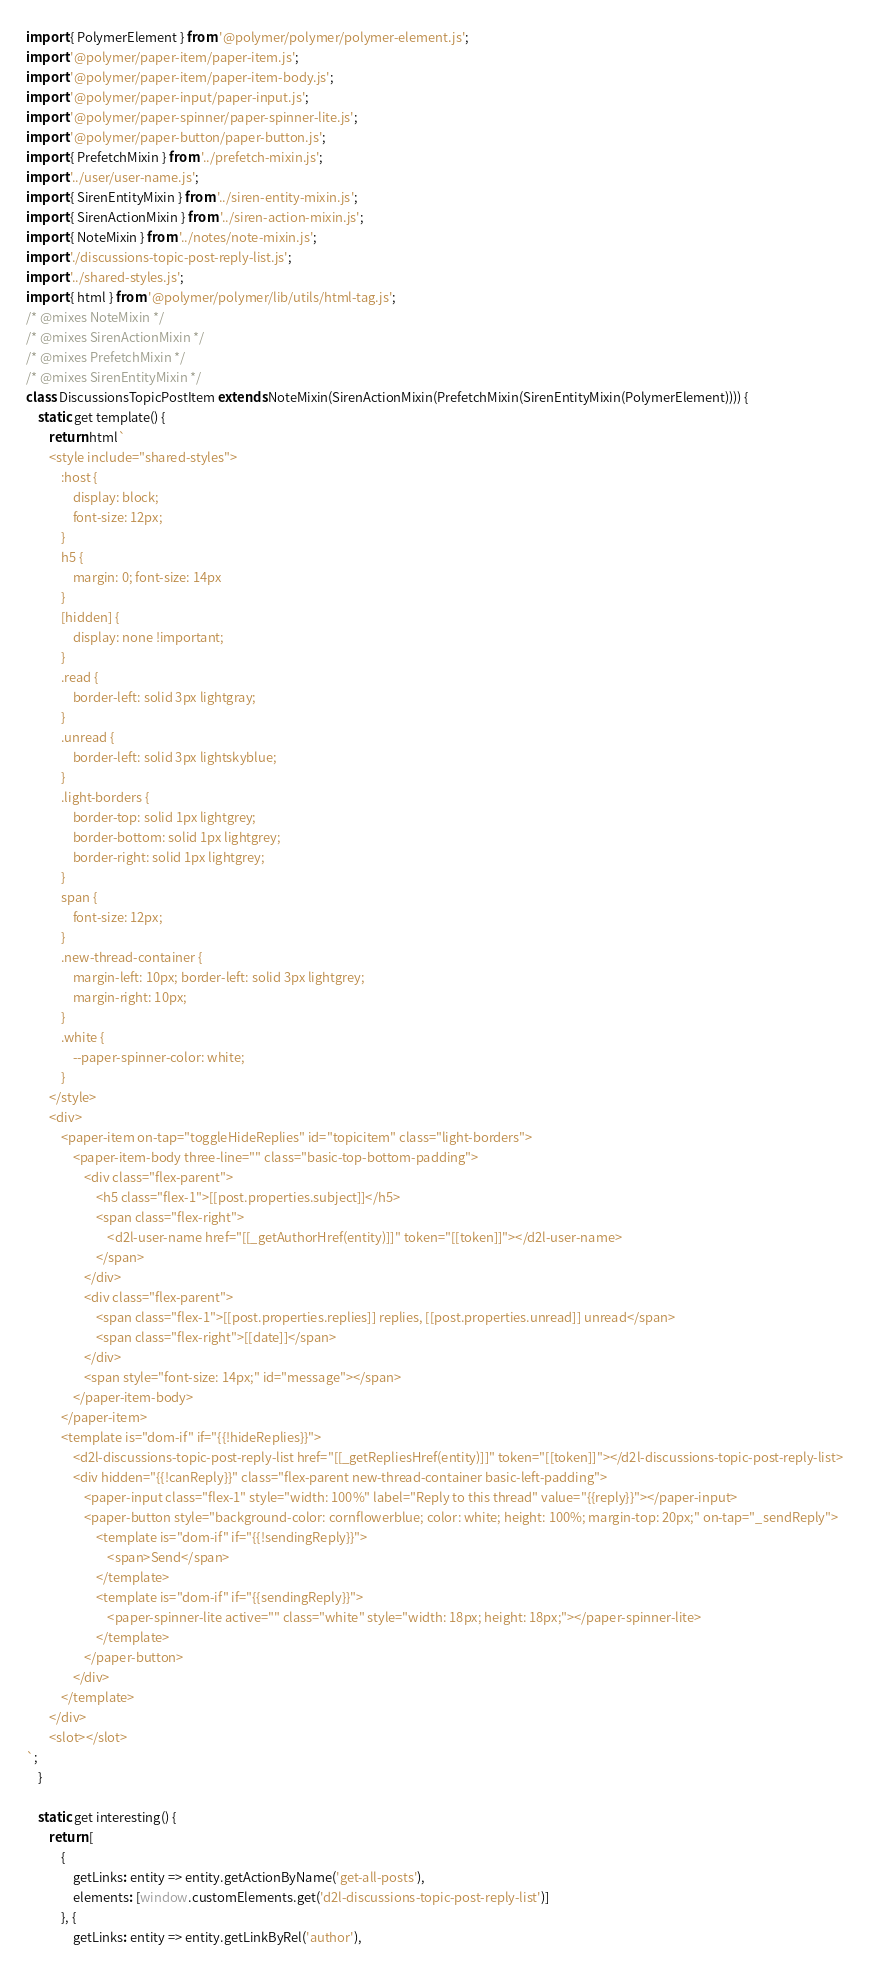<code> <loc_0><loc_0><loc_500><loc_500><_JavaScript_>import { PolymerElement } from '@polymer/polymer/polymer-element.js';
import '@polymer/paper-item/paper-item.js';
import '@polymer/paper-item/paper-item-body.js';
import '@polymer/paper-input/paper-input.js';
import '@polymer/paper-spinner/paper-spinner-lite.js';
import '@polymer/paper-button/paper-button.js';
import { PrefetchMixin } from '../prefetch-mixin.js';
import '../user/user-name.js';
import { SirenEntityMixin } from '../siren-entity-mixin.js';
import { SirenActionMixin } from '../siren-action-mixin.js';
import { NoteMixin } from '../notes/note-mixin.js';
import './discussions-topic-post-reply-list.js';
import '../shared-styles.js';
import { html } from '@polymer/polymer/lib/utils/html-tag.js';
/* @mixes NoteMixin */
/* @mixes SirenActionMixin */
/* @mixes PrefetchMixin */
/* @mixes SirenEntityMixin */
class DiscussionsTopicPostItem extends NoteMixin(SirenActionMixin(PrefetchMixin(SirenEntityMixin(PolymerElement)))) {
	static get template() {
		return html`
        <style include="shared-styles">
            :host {
                display: block;
                font-size: 12px;
            }
            h5 {
                margin: 0; font-size: 14px
            }
            [hidden] {
                display: none !important;
            }
            .read {
                border-left: solid 3px lightgray;
            }
            .unread {
                border-left: solid 3px lightskyblue;
            }
            .light-borders {
                border-top: solid 1px lightgrey;
                border-bottom: solid 1px lightgrey;
                border-right: solid 1px lightgrey;
            }
            span {
                font-size: 12px;
            }
            .new-thread-container {
                margin-left: 10px; border-left: solid 3px lightgrey;
                margin-right: 10px;
            }
            .white {
                --paper-spinner-color: white;
            }
        </style>
        <div>
            <paper-item on-tap="toggleHideReplies" id="topicitem" class="light-borders">
                <paper-item-body three-line="" class="basic-top-bottom-padding">
                    <div class="flex-parent">
                        <h5 class="flex-1">[[post.properties.subject]]</h5>
                        <span class="flex-right">
                            <d2l-user-name href="[[_getAuthorHref(entity)]]" token="[[token]]"></d2l-user-name>
                        </span>
                    </div>
                    <div class="flex-parent">
                        <span class="flex-1">[[post.properties.replies]] replies, [[post.properties.unread]] unread</span>
                        <span class="flex-right">[[date]]</span>
                    </div>
                    <span style="font-size: 14px;" id="message"></span>
                </paper-item-body>
            </paper-item>
            <template is="dom-if" if="{{!hideReplies}}">
                <d2l-discussions-topic-post-reply-list href="[[_getRepliesHref(entity)]]" token="[[token]]"></d2l-discussions-topic-post-reply-list>
                <div hidden="{{!canReply}}" class="flex-parent new-thread-container basic-left-padding">
                    <paper-input class="flex-1" style="width: 100%" label="Reply to this thread" value="{{reply}}"></paper-input>
                    <paper-button style="background-color: cornflowerblue; color: white; height: 100%; margin-top: 20px;" on-tap="_sendReply">
                        <template is="dom-if" if="{{!sendingReply}}">
                            <span>Send</span>
                        </template>
                        <template is="dom-if" if="{{sendingReply}}">
                            <paper-spinner-lite active="" class="white" style="width: 18px; height: 18px;"></paper-spinner-lite>
                        </template>
                    </paper-button>
                </div>
            </template>
        </div>
        <slot></slot>
`;
	}

	static get interesting() {
		return [
			{
				getLinks: entity => entity.getActionByName('get-all-posts'),
				elements: [window.customElements.get('d2l-discussions-topic-post-reply-list')]
			}, {
				getLinks: entity => entity.getLinkByRel('author'),</code> 